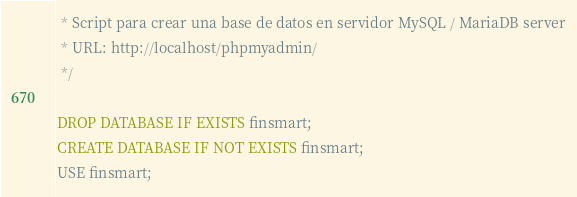<code> <loc_0><loc_0><loc_500><loc_500><_SQL_> * Script para crear una base de datos en servidor MySQL / MariaDB server
 * URL: http://localhost/phpmyadmin/
 */

DROP DATABASE IF EXISTS finsmart;
CREATE DATABASE IF NOT EXISTS finsmart;
USE finsmart;</code> 